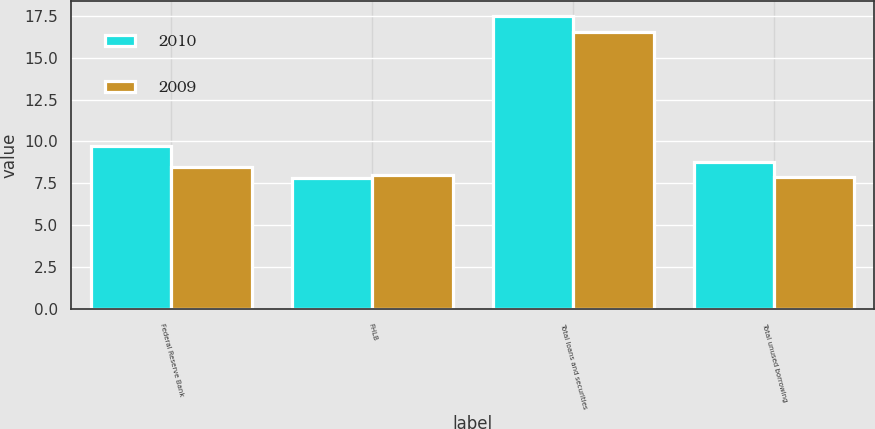Convert chart. <chart><loc_0><loc_0><loc_500><loc_500><stacked_bar_chart><ecel><fcel>Federal Reserve Bank<fcel>FHLB<fcel>Total loans and securities<fcel>Total unused borrowing<nl><fcel>2010<fcel>9.7<fcel>7.8<fcel>17.5<fcel>8.8<nl><fcel>2009<fcel>8.5<fcel>8<fcel>16.5<fcel>7.9<nl></chart> 